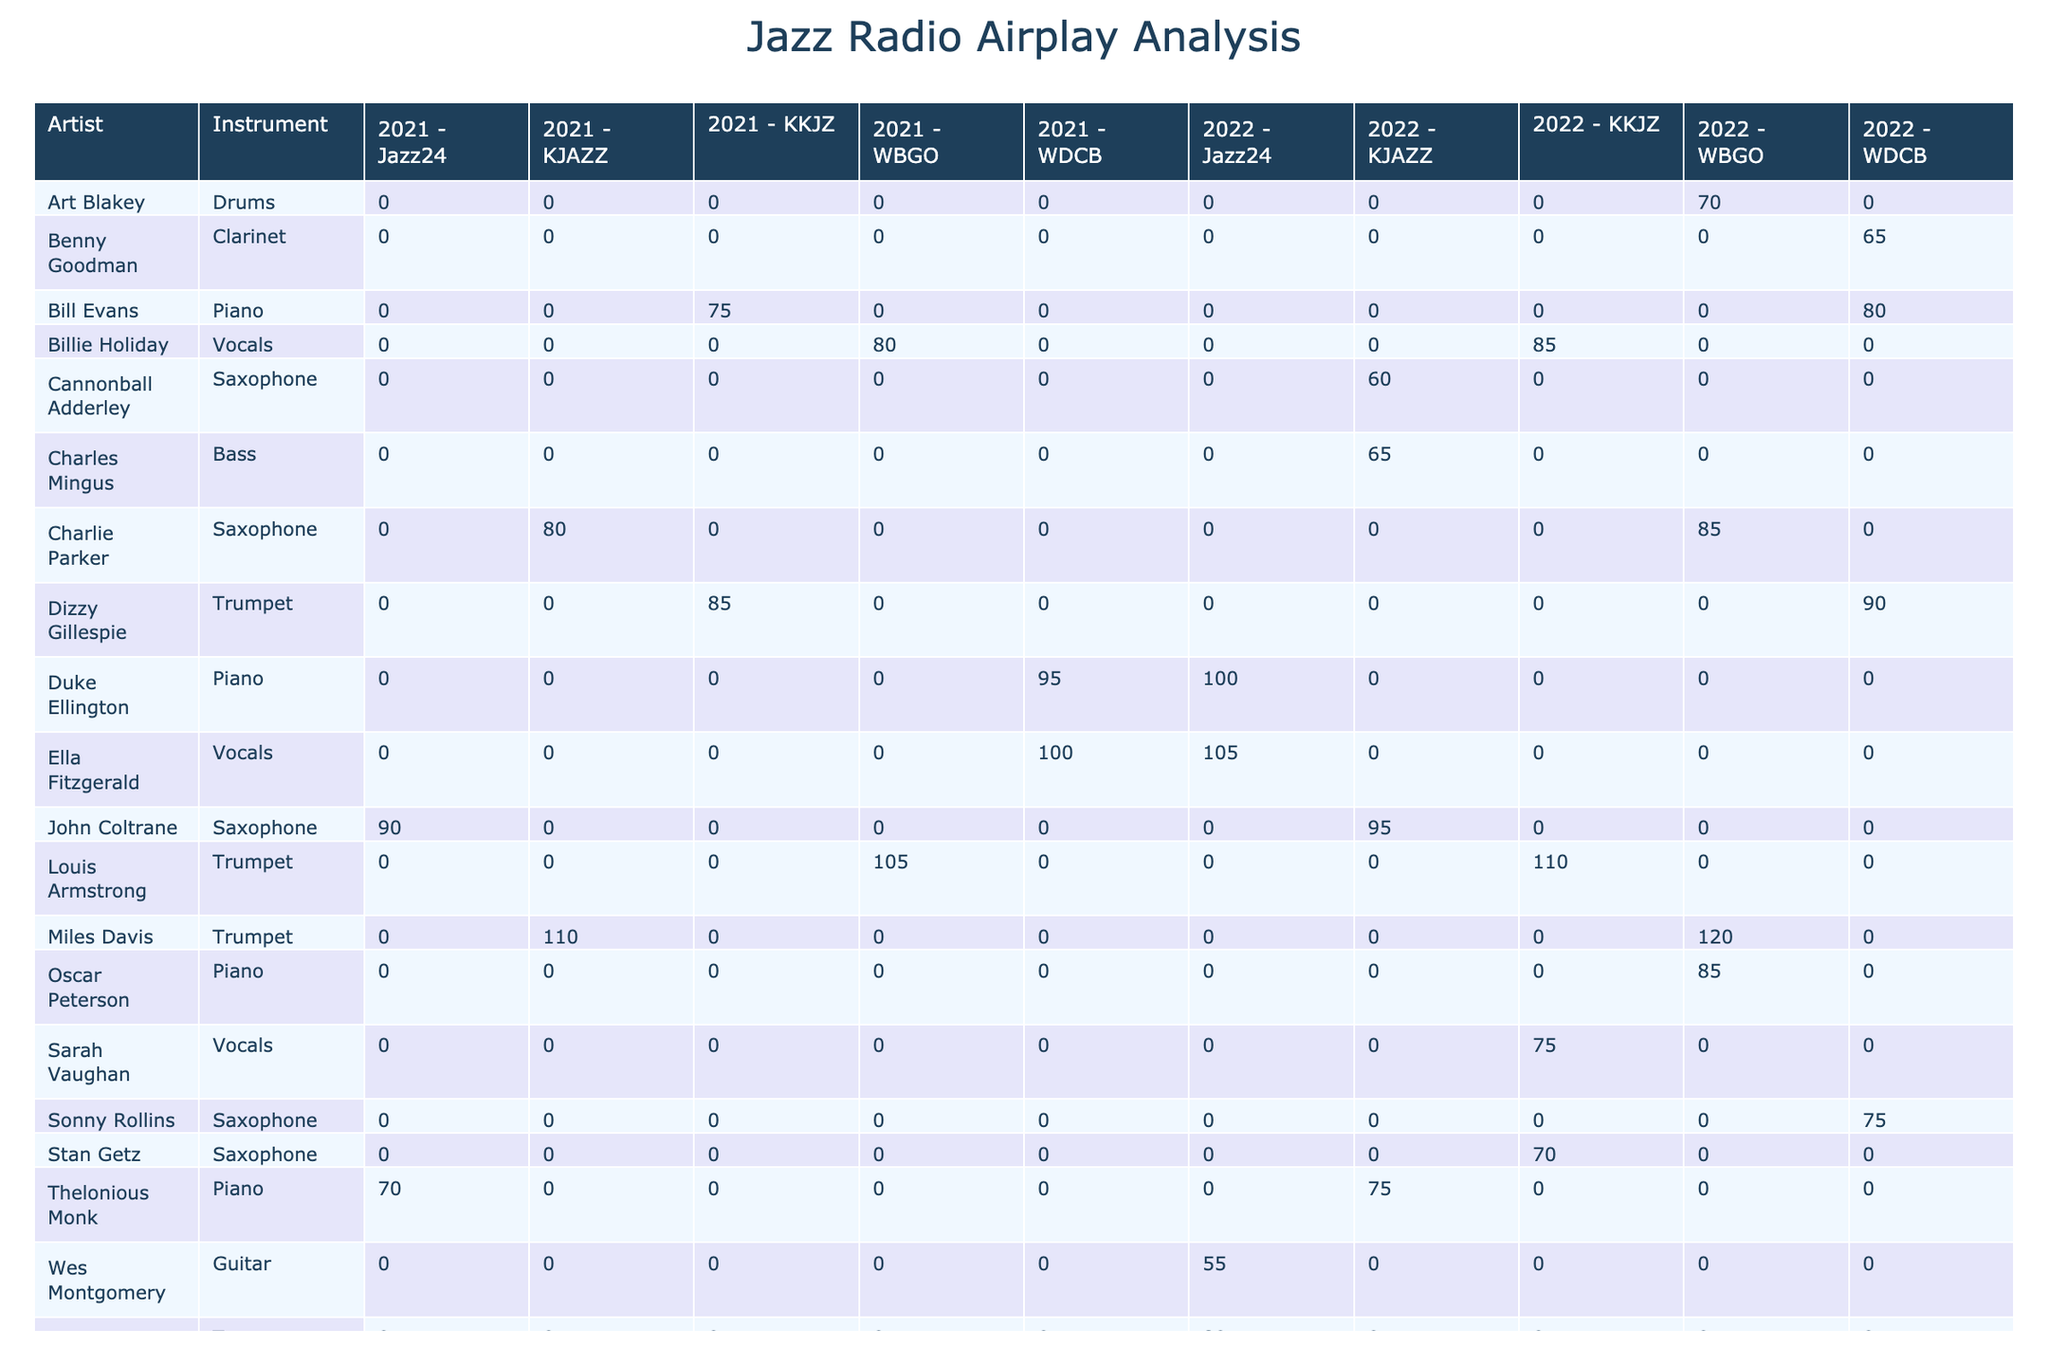What is the total airplay time for Louis Armstrong in 2022? To find this, we look for all entries for Louis Armstrong in 2022 in the table. There is one entry showing 110 minutes of airplay on KKJZ and another showing 105 minutes on WBGO. Summing these gives 110 + 105 = 215 minutes.
Answer: 215 minutes Which artist played the saxophone and had the highest airplay minutes in 2021? We need to check the saxophone players in 2021 from the table. The artists and their airplay minutes are: John Coltrane (90), Charlie Parker (80), and Stan Getz (70). The highest among these is John Coltrane with 90 minutes.
Answer: John Coltrane Did Billie Holiday have more airplay minutes in 2022 compared to 2021? Checking the table, Billie Holiday's airplay minutes are 85 in 2022 and 80 in 2021. Since 85 is greater than 80, the answer is yes.
Answer: Yes What is the total airplay time for all trumpet players in 2022? We look for entries with the "Trumpet" instrument in 2022. The trumpet players are Miles Davis (120), Louis Armstrong (110), Dizzy Gillespie (90), and Wynton Marsalis (80). Adding these gives 120 + 110 + 90 + 80 = 400 minutes.
Answer: 400 minutes Who had the least airplay minutes among the vocalists in 2021? Analyzing the airplay minutes for vocalists in 2021 from the table, we find Ella Fitzgerald (100) and Billie Holiday (80). So, Billie Holiday has the least with 80 minutes.
Answer: Billie Holiday How much airplay time did the piano artists collectively receive in 2022? We list the airplay minutes for piano artists from 2022: Bill Evans (80), Thelonious Monk (75), Duke Ellington (100), and Oscar Peterson (85). Summing these values results in 80 + 75 + 100 + 85 = 340 minutes.
Answer: 340 minutes Is there any saxophone player with more than 90 airplay minutes in 2022? Checking the saxophone players for 2022, we have John Coltrane with 95 and Sonny Rollins with 75. Since John Coltrane has more than 90, the answer is yes.
Answer: Yes Which instrument had the highest total airplay minutes in 2021? To determine this, we need to add all instruments' airplay minutes in 2021: for horns (trumpet): Miles Davis (110) + Louis Armstrong (105) + Dizzy Gillespie (85) = 300, saxophone: John Coltrane (90) + Charlie Parker (80) + Stan Getz (70) = 240, piano: Bill Evans (75) + Duke Ellington (95) + Thelonious Monk (70) = 240, vocals: Ella Fitzgerald (100) + Billie Holiday (80) = 180. The highest is trumpet with 300 minutes.
Answer: Trumpet 